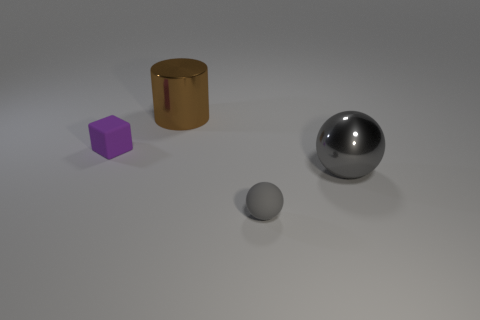Add 2 yellow objects. How many objects exist? 6 Subtract all cylinders. How many objects are left? 3 Subtract all tiny brown matte cylinders. Subtract all large shiny cylinders. How many objects are left? 3 Add 1 large brown metallic things. How many large brown metallic things are left? 2 Add 3 big purple metallic things. How many big purple metallic things exist? 3 Subtract 0 green cubes. How many objects are left? 4 